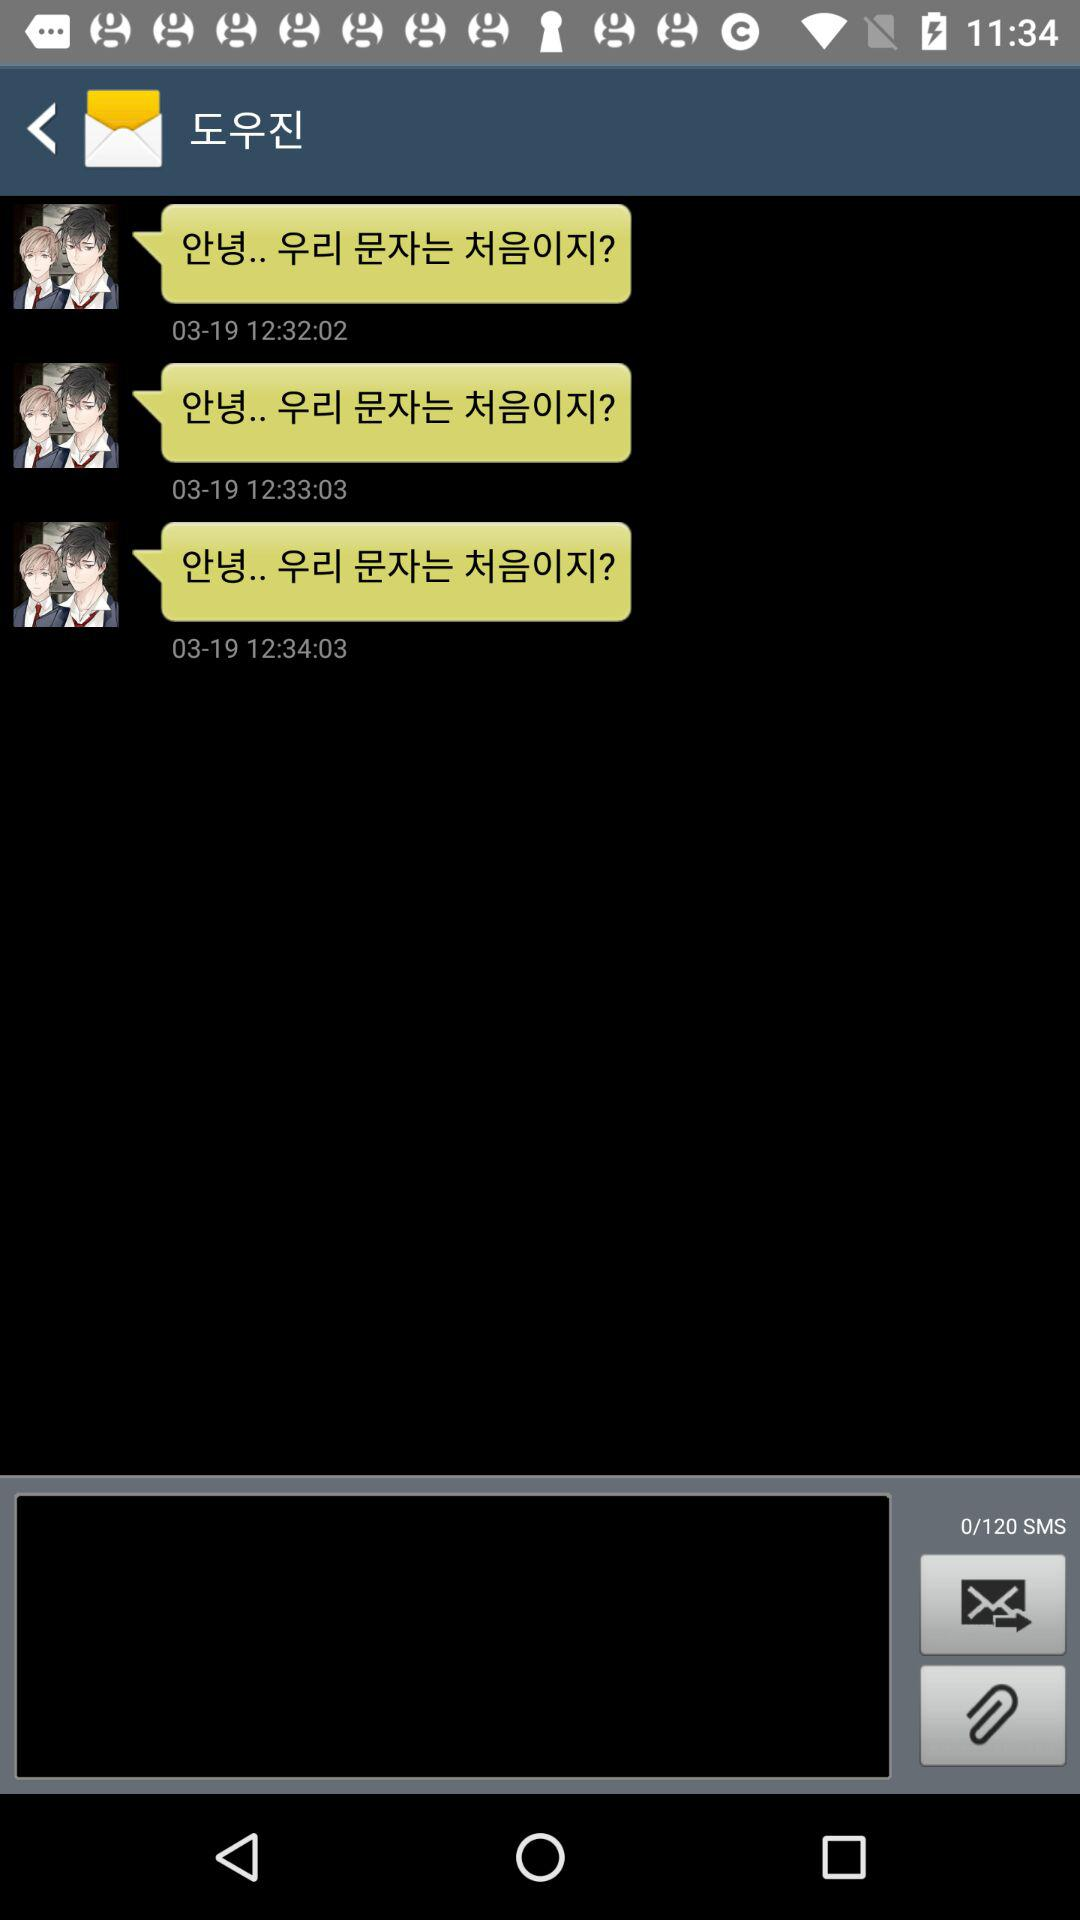How many messages are in the conversation?
Answer the question using a single word or phrase. 3 